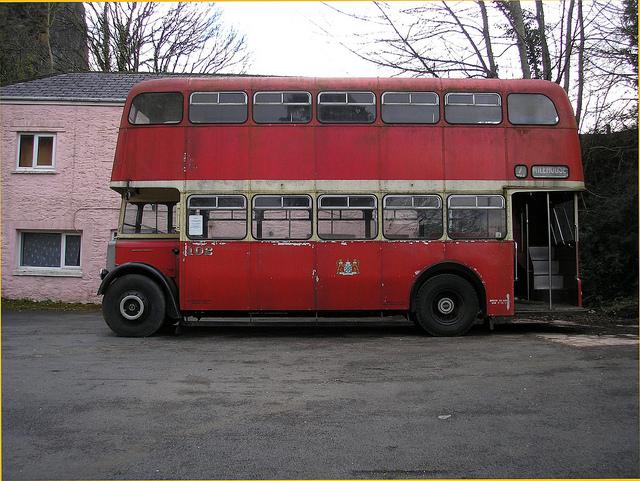What is behind the bus?
Write a very short answer. Building. Is the bus air conditioned?
Write a very short answer. No. What is the bus doing?
Short answer required. Parked. How many stories on the bus?
Short answer required. 2. What color is building?
Write a very short answer. Pink. 